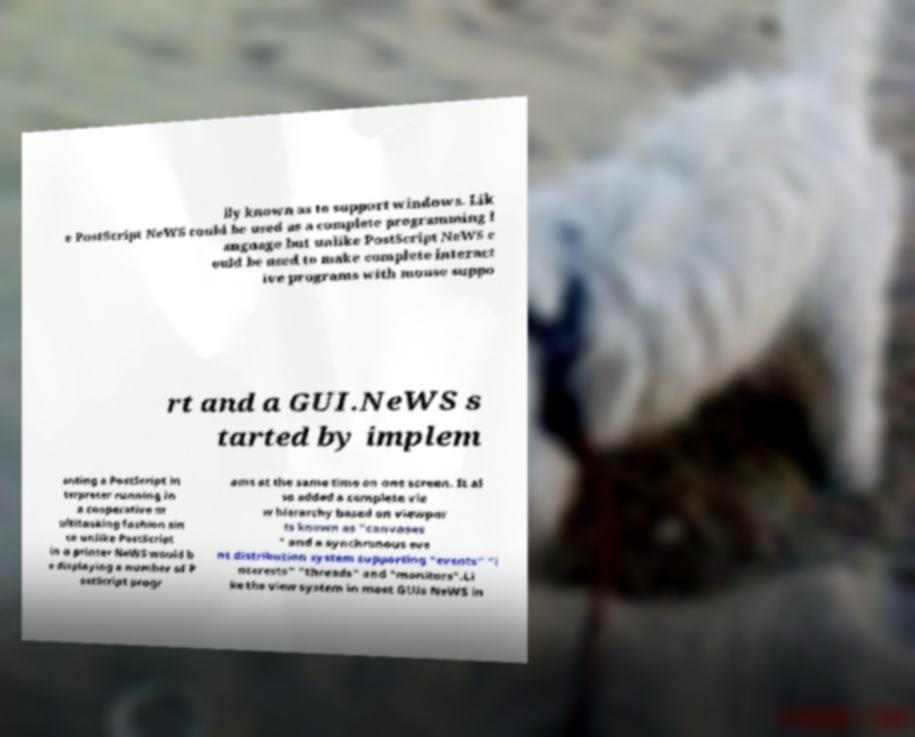I need the written content from this picture converted into text. Can you do that? lly known as to support windows. Lik e PostScript NeWS could be used as a complete programming l anguage but unlike PostScript NeWS c ould be used to make complete interact ive programs with mouse suppo rt and a GUI.NeWS s tarted by implem enting a PostScript in terpreter running in a cooperative m ultitasking fashion sin ce unlike PostScript in a printer NeWS would b e displaying a number of P ostScript progr ams at the same time on one screen. It al so added a complete vie w hierarchy based on viewpor ts known as "canvases " and a synchronous eve nt distribution system supporting "events" "i nterests" "threads" and "monitors".Li ke the view system in most GUIs NeWS in 